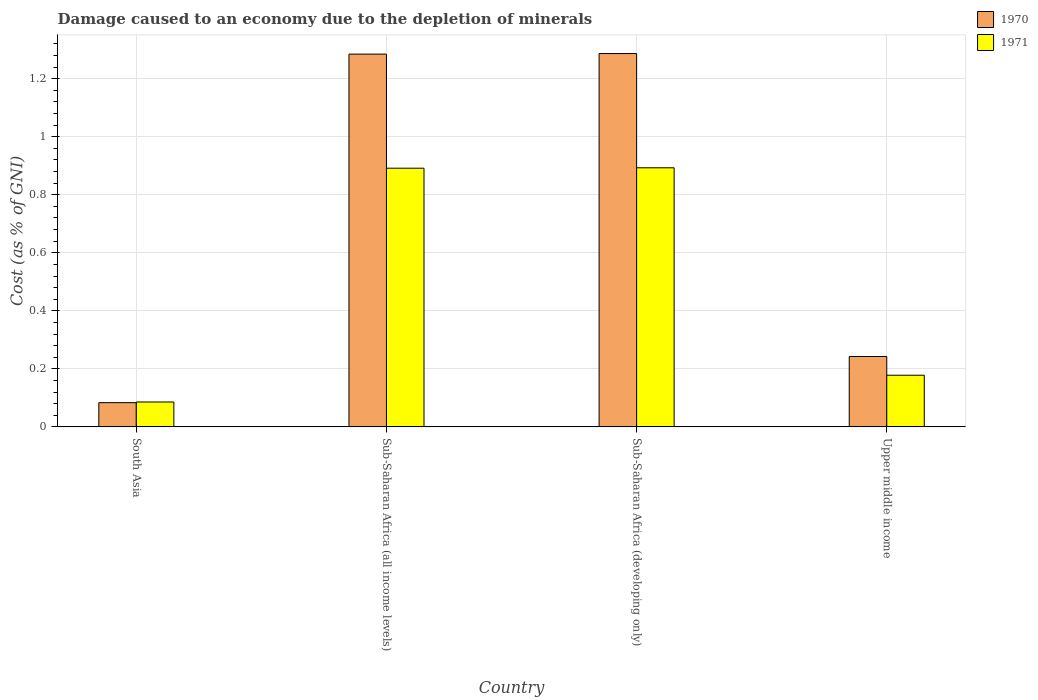How many different coloured bars are there?
Keep it short and to the point. 2. How many groups of bars are there?
Give a very brief answer. 4. Are the number of bars per tick equal to the number of legend labels?
Make the answer very short. Yes. How many bars are there on the 4th tick from the right?
Offer a very short reply. 2. What is the label of the 3rd group of bars from the left?
Provide a succinct answer. Sub-Saharan Africa (developing only). What is the cost of damage caused due to the depletion of minerals in 1970 in Sub-Saharan Africa (all income levels)?
Make the answer very short. 1.28. Across all countries, what is the maximum cost of damage caused due to the depletion of minerals in 1970?
Your answer should be compact. 1.29. Across all countries, what is the minimum cost of damage caused due to the depletion of minerals in 1970?
Provide a short and direct response. 0.08. In which country was the cost of damage caused due to the depletion of minerals in 1971 maximum?
Give a very brief answer. Sub-Saharan Africa (developing only). What is the total cost of damage caused due to the depletion of minerals in 1971 in the graph?
Ensure brevity in your answer.  2.05. What is the difference between the cost of damage caused due to the depletion of minerals in 1971 in South Asia and that in Upper middle income?
Make the answer very short. -0.09. What is the difference between the cost of damage caused due to the depletion of minerals in 1971 in Upper middle income and the cost of damage caused due to the depletion of minerals in 1970 in Sub-Saharan Africa (all income levels)?
Ensure brevity in your answer.  -1.11. What is the average cost of damage caused due to the depletion of minerals in 1971 per country?
Give a very brief answer. 0.51. What is the difference between the cost of damage caused due to the depletion of minerals of/in 1970 and cost of damage caused due to the depletion of minerals of/in 1971 in Upper middle income?
Your response must be concise. 0.06. What is the ratio of the cost of damage caused due to the depletion of minerals in 1971 in Sub-Saharan Africa (all income levels) to that in Upper middle income?
Offer a terse response. 5.01. Is the cost of damage caused due to the depletion of minerals in 1971 in South Asia less than that in Upper middle income?
Offer a terse response. Yes. What is the difference between the highest and the second highest cost of damage caused due to the depletion of minerals in 1970?
Ensure brevity in your answer.  -1.04. What is the difference between the highest and the lowest cost of damage caused due to the depletion of minerals in 1970?
Your answer should be compact. 1.2. In how many countries, is the cost of damage caused due to the depletion of minerals in 1970 greater than the average cost of damage caused due to the depletion of minerals in 1970 taken over all countries?
Your answer should be very brief. 2. Is the sum of the cost of damage caused due to the depletion of minerals in 1971 in South Asia and Upper middle income greater than the maximum cost of damage caused due to the depletion of minerals in 1970 across all countries?
Keep it short and to the point. No. What does the 2nd bar from the left in Upper middle income represents?
Give a very brief answer. 1971. What does the 2nd bar from the right in Upper middle income represents?
Your answer should be very brief. 1970. Does the graph contain any zero values?
Keep it short and to the point. No. Does the graph contain grids?
Provide a short and direct response. Yes. Where does the legend appear in the graph?
Keep it short and to the point. Top right. How many legend labels are there?
Offer a terse response. 2. What is the title of the graph?
Offer a terse response. Damage caused to an economy due to the depletion of minerals. What is the label or title of the X-axis?
Make the answer very short. Country. What is the label or title of the Y-axis?
Provide a short and direct response. Cost (as % of GNI). What is the Cost (as % of GNI) in 1970 in South Asia?
Your response must be concise. 0.08. What is the Cost (as % of GNI) of 1971 in South Asia?
Your response must be concise. 0.09. What is the Cost (as % of GNI) of 1970 in Sub-Saharan Africa (all income levels)?
Give a very brief answer. 1.28. What is the Cost (as % of GNI) in 1971 in Sub-Saharan Africa (all income levels)?
Your answer should be compact. 0.89. What is the Cost (as % of GNI) in 1970 in Sub-Saharan Africa (developing only)?
Your answer should be compact. 1.29. What is the Cost (as % of GNI) of 1971 in Sub-Saharan Africa (developing only)?
Provide a succinct answer. 0.89. What is the Cost (as % of GNI) in 1970 in Upper middle income?
Your response must be concise. 0.24. What is the Cost (as % of GNI) in 1971 in Upper middle income?
Offer a terse response. 0.18. Across all countries, what is the maximum Cost (as % of GNI) in 1970?
Your answer should be very brief. 1.29. Across all countries, what is the maximum Cost (as % of GNI) of 1971?
Offer a very short reply. 0.89. Across all countries, what is the minimum Cost (as % of GNI) in 1970?
Your answer should be compact. 0.08. Across all countries, what is the minimum Cost (as % of GNI) in 1971?
Your answer should be very brief. 0.09. What is the total Cost (as % of GNI) in 1970 in the graph?
Offer a terse response. 2.9. What is the total Cost (as % of GNI) in 1971 in the graph?
Your answer should be very brief. 2.05. What is the difference between the Cost (as % of GNI) in 1970 in South Asia and that in Sub-Saharan Africa (all income levels)?
Your answer should be very brief. -1.2. What is the difference between the Cost (as % of GNI) of 1971 in South Asia and that in Sub-Saharan Africa (all income levels)?
Ensure brevity in your answer.  -0.81. What is the difference between the Cost (as % of GNI) of 1970 in South Asia and that in Sub-Saharan Africa (developing only)?
Your answer should be very brief. -1.2. What is the difference between the Cost (as % of GNI) in 1971 in South Asia and that in Sub-Saharan Africa (developing only)?
Give a very brief answer. -0.81. What is the difference between the Cost (as % of GNI) of 1970 in South Asia and that in Upper middle income?
Make the answer very short. -0.16. What is the difference between the Cost (as % of GNI) in 1971 in South Asia and that in Upper middle income?
Provide a short and direct response. -0.09. What is the difference between the Cost (as % of GNI) in 1970 in Sub-Saharan Africa (all income levels) and that in Sub-Saharan Africa (developing only)?
Your answer should be compact. -0. What is the difference between the Cost (as % of GNI) of 1971 in Sub-Saharan Africa (all income levels) and that in Sub-Saharan Africa (developing only)?
Ensure brevity in your answer.  -0. What is the difference between the Cost (as % of GNI) in 1970 in Sub-Saharan Africa (all income levels) and that in Upper middle income?
Provide a short and direct response. 1.04. What is the difference between the Cost (as % of GNI) in 1971 in Sub-Saharan Africa (all income levels) and that in Upper middle income?
Keep it short and to the point. 0.71. What is the difference between the Cost (as % of GNI) of 1970 in Sub-Saharan Africa (developing only) and that in Upper middle income?
Ensure brevity in your answer.  1.04. What is the difference between the Cost (as % of GNI) of 1971 in Sub-Saharan Africa (developing only) and that in Upper middle income?
Your response must be concise. 0.71. What is the difference between the Cost (as % of GNI) in 1970 in South Asia and the Cost (as % of GNI) in 1971 in Sub-Saharan Africa (all income levels)?
Provide a succinct answer. -0.81. What is the difference between the Cost (as % of GNI) of 1970 in South Asia and the Cost (as % of GNI) of 1971 in Sub-Saharan Africa (developing only)?
Make the answer very short. -0.81. What is the difference between the Cost (as % of GNI) in 1970 in South Asia and the Cost (as % of GNI) in 1971 in Upper middle income?
Give a very brief answer. -0.09. What is the difference between the Cost (as % of GNI) of 1970 in Sub-Saharan Africa (all income levels) and the Cost (as % of GNI) of 1971 in Sub-Saharan Africa (developing only)?
Offer a terse response. 0.39. What is the difference between the Cost (as % of GNI) of 1970 in Sub-Saharan Africa (all income levels) and the Cost (as % of GNI) of 1971 in Upper middle income?
Give a very brief answer. 1.11. What is the difference between the Cost (as % of GNI) of 1970 in Sub-Saharan Africa (developing only) and the Cost (as % of GNI) of 1971 in Upper middle income?
Offer a very short reply. 1.11. What is the average Cost (as % of GNI) of 1970 per country?
Your answer should be compact. 0.72. What is the average Cost (as % of GNI) of 1971 per country?
Provide a short and direct response. 0.51. What is the difference between the Cost (as % of GNI) in 1970 and Cost (as % of GNI) in 1971 in South Asia?
Your answer should be very brief. -0. What is the difference between the Cost (as % of GNI) of 1970 and Cost (as % of GNI) of 1971 in Sub-Saharan Africa (all income levels)?
Ensure brevity in your answer.  0.39. What is the difference between the Cost (as % of GNI) in 1970 and Cost (as % of GNI) in 1971 in Sub-Saharan Africa (developing only)?
Your answer should be very brief. 0.39. What is the difference between the Cost (as % of GNI) of 1970 and Cost (as % of GNI) of 1971 in Upper middle income?
Ensure brevity in your answer.  0.06. What is the ratio of the Cost (as % of GNI) in 1970 in South Asia to that in Sub-Saharan Africa (all income levels)?
Keep it short and to the point. 0.06. What is the ratio of the Cost (as % of GNI) of 1971 in South Asia to that in Sub-Saharan Africa (all income levels)?
Ensure brevity in your answer.  0.1. What is the ratio of the Cost (as % of GNI) in 1970 in South Asia to that in Sub-Saharan Africa (developing only)?
Ensure brevity in your answer.  0.06. What is the ratio of the Cost (as % of GNI) of 1971 in South Asia to that in Sub-Saharan Africa (developing only)?
Your answer should be compact. 0.1. What is the ratio of the Cost (as % of GNI) of 1970 in South Asia to that in Upper middle income?
Make the answer very short. 0.34. What is the ratio of the Cost (as % of GNI) of 1971 in South Asia to that in Upper middle income?
Give a very brief answer. 0.48. What is the ratio of the Cost (as % of GNI) in 1970 in Sub-Saharan Africa (all income levels) to that in Sub-Saharan Africa (developing only)?
Give a very brief answer. 1. What is the ratio of the Cost (as % of GNI) of 1970 in Sub-Saharan Africa (all income levels) to that in Upper middle income?
Your answer should be compact. 5.3. What is the ratio of the Cost (as % of GNI) in 1971 in Sub-Saharan Africa (all income levels) to that in Upper middle income?
Keep it short and to the point. 5.01. What is the ratio of the Cost (as % of GNI) of 1970 in Sub-Saharan Africa (developing only) to that in Upper middle income?
Provide a succinct answer. 5.31. What is the ratio of the Cost (as % of GNI) in 1971 in Sub-Saharan Africa (developing only) to that in Upper middle income?
Your answer should be compact. 5.02. What is the difference between the highest and the second highest Cost (as % of GNI) in 1970?
Keep it short and to the point. 0. What is the difference between the highest and the second highest Cost (as % of GNI) of 1971?
Give a very brief answer. 0. What is the difference between the highest and the lowest Cost (as % of GNI) in 1970?
Your response must be concise. 1.2. What is the difference between the highest and the lowest Cost (as % of GNI) of 1971?
Provide a succinct answer. 0.81. 